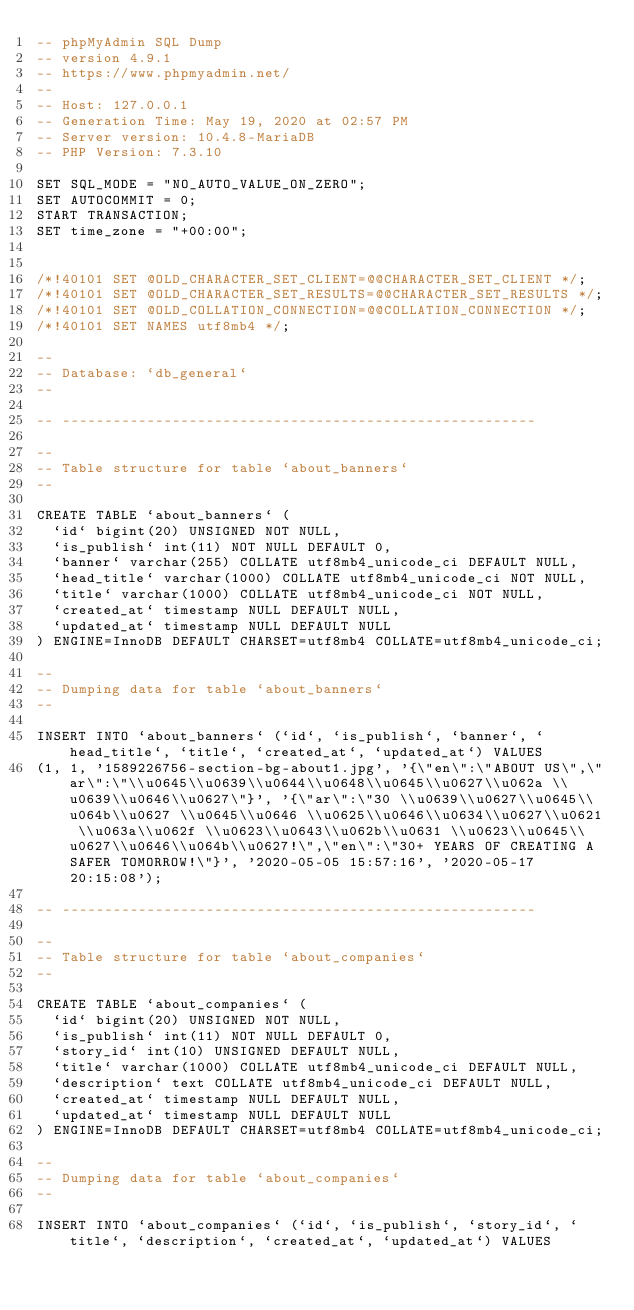<code> <loc_0><loc_0><loc_500><loc_500><_SQL_>-- phpMyAdmin SQL Dump
-- version 4.9.1
-- https://www.phpmyadmin.net/
--
-- Host: 127.0.0.1
-- Generation Time: May 19, 2020 at 02:57 PM
-- Server version: 10.4.8-MariaDB
-- PHP Version: 7.3.10

SET SQL_MODE = "NO_AUTO_VALUE_ON_ZERO";
SET AUTOCOMMIT = 0;
START TRANSACTION;
SET time_zone = "+00:00";


/*!40101 SET @OLD_CHARACTER_SET_CLIENT=@@CHARACTER_SET_CLIENT */;
/*!40101 SET @OLD_CHARACTER_SET_RESULTS=@@CHARACTER_SET_RESULTS */;
/*!40101 SET @OLD_COLLATION_CONNECTION=@@COLLATION_CONNECTION */;
/*!40101 SET NAMES utf8mb4 */;

--
-- Database: `db_general`
--

-- --------------------------------------------------------

--
-- Table structure for table `about_banners`
--

CREATE TABLE `about_banners` (
  `id` bigint(20) UNSIGNED NOT NULL,
  `is_publish` int(11) NOT NULL DEFAULT 0,
  `banner` varchar(255) COLLATE utf8mb4_unicode_ci DEFAULT NULL,
  `head_title` varchar(1000) COLLATE utf8mb4_unicode_ci NOT NULL,
  `title` varchar(1000) COLLATE utf8mb4_unicode_ci NOT NULL,
  `created_at` timestamp NULL DEFAULT NULL,
  `updated_at` timestamp NULL DEFAULT NULL
) ENGINE=InnoDB DEFAULT CHARSET=utf8mb4 COLLATE=utf8mb4_unicode_ci;

--
-- Dumping data for table `about_banners`
--

INSERT INTO `about_banners` (`id`, `is_publish`, `banner`, `head_title`, `title`, `created_at`, `updated_at`) VALUES
(1, 1, '1589226756-section-bg-about1.jpg', '{\"en\":\"ABOUT US\",\"ar\":\"\\u0645\\u0639\\u0644\\u0648\\u0645\\u0627\\u062a \\u0639\\u0646\\u0627\"}', '{\"ar\":\"30 \\u0639\\u0627\\u0645\\u064b\\u0627 \\u0645\\u0646 \\u0625\\u0646\\u0634\\u0627\\u0621 \\u063a\\u062f \\u0623\\u0643\\u062b\\u0631 \\u0623\\u0645\\u0627\\u0646\\u064b\\u0627!\",\"en\":\"30+ YEARS OF CREATING A SAFER TOMORROW!\"}', '2020-05-05 15:57:16', '2020-05-17 20:15:08');

-- --------------------------------------------------------

--
-- Table structure for table `about_companies`
--

CREATE TABLE `about_companies` (
  `id` bigint(20) UNSIGNED NOT NULL,
  `is_publish` int(11) NOT NULL DEFAULT 0,
  `story_id` int(10) UNSIGNED DEFAULT NULL,
  `title` varchar(1000) COLLATE utf8mb4_unicode_ci DEFAULT NULL,
  `description` text COLLATE utf8mb4_unicode_ci DEFAULT NULL,
  `created_at` timestamp NULL DEFAULT NULL,
  `updated_at` timestamp NULL DEFAULT NULL
) ENGINE=InnoDB DEFAULT CHARSET=utf8mb4 COLLATE=utf8mb4_unicode_ci;

--
-- Dumping data for table `about_companies`
--

INSERT INTO `about_companies` (`id`, `is_publish`, `story_id`, `title`, `description`, `created_at`, `updated_at`) VALUES</code> 